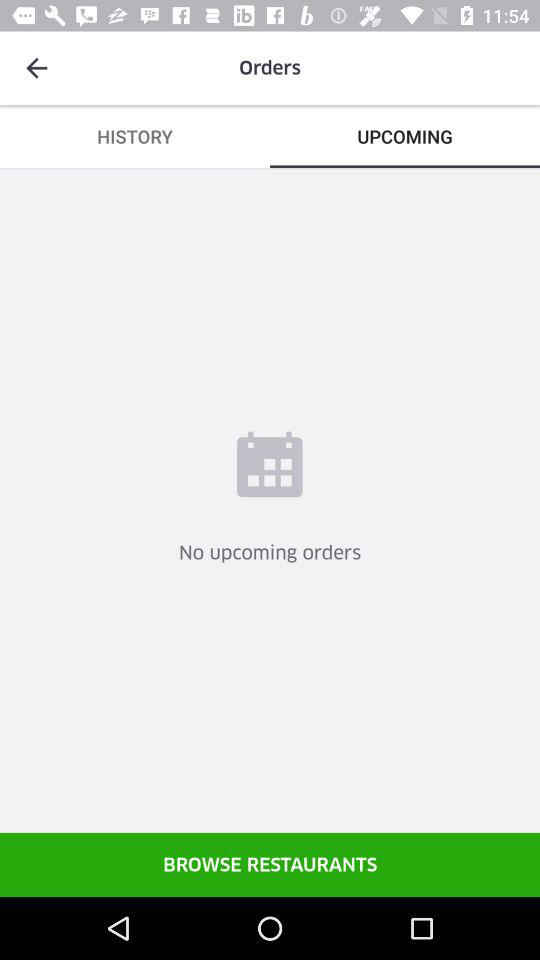Are there any upcoming orders? There are no upcoming orders. 